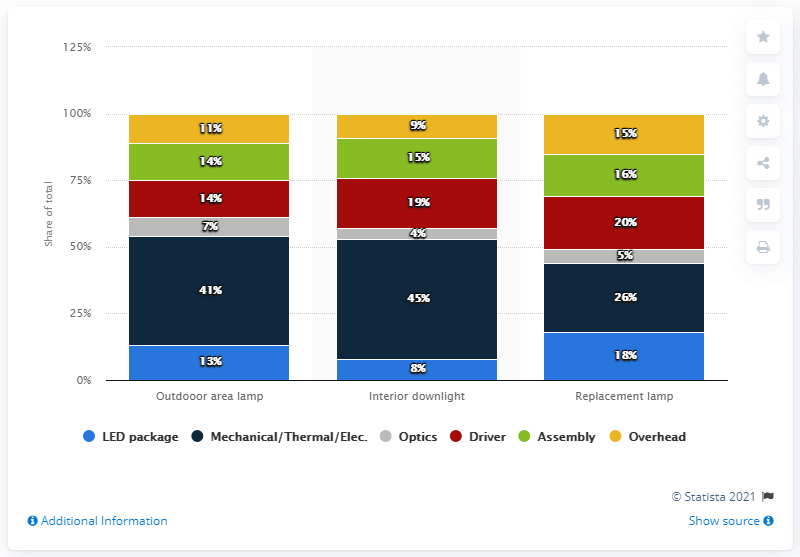Highlight a few significant elements in this photo. The difference between driver luminaires used in interior downlights and outdoor area lamps is 5... The second most popular luminary in the field of interior downlighting is the driver. 